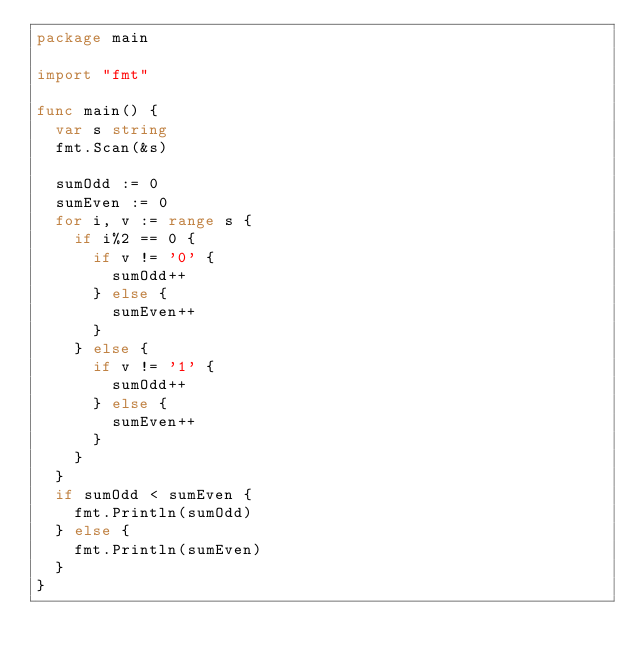Convert code to text. <code><loc_0><loc_0><loc_500><loc_500><_Go_>package main

import "fmt"

func main() {
	var s string
	fmt.Scan(&s)

	sumOdd := 0
	sumEven := 0
	for i, v := range s {
		if i%2 == 0 {
			if v != '0' {
				sumOdd++
			} else {
				sumEven++
			}
		} else {
			if v != '1' {
				sumOdd++
			} else {
				sumEven++
			}
		}
	}
	if sumOdd < sumEven {
		fmt.Println(sumOdd)
	} else {
		fmt.Println(sumEven)
	}
}
</code> 